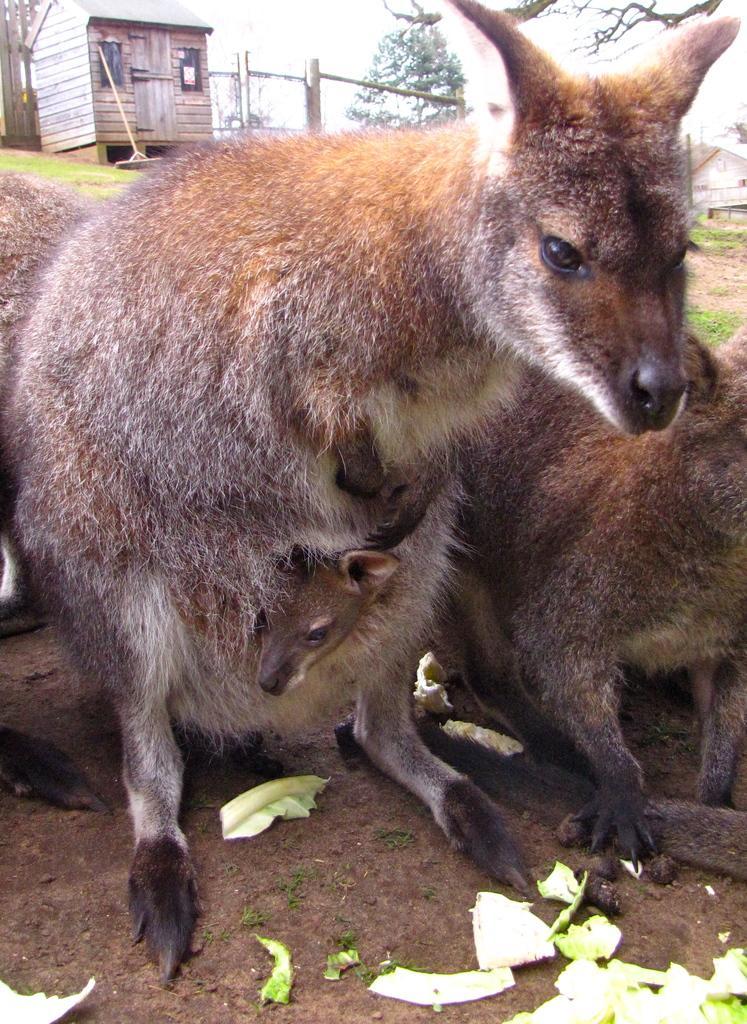Could you give a brief overview of what you see in this image? In this image there are animals. In the background there is a shed and we can see trees. There is sky. At the bottom we can see some vegetables. 